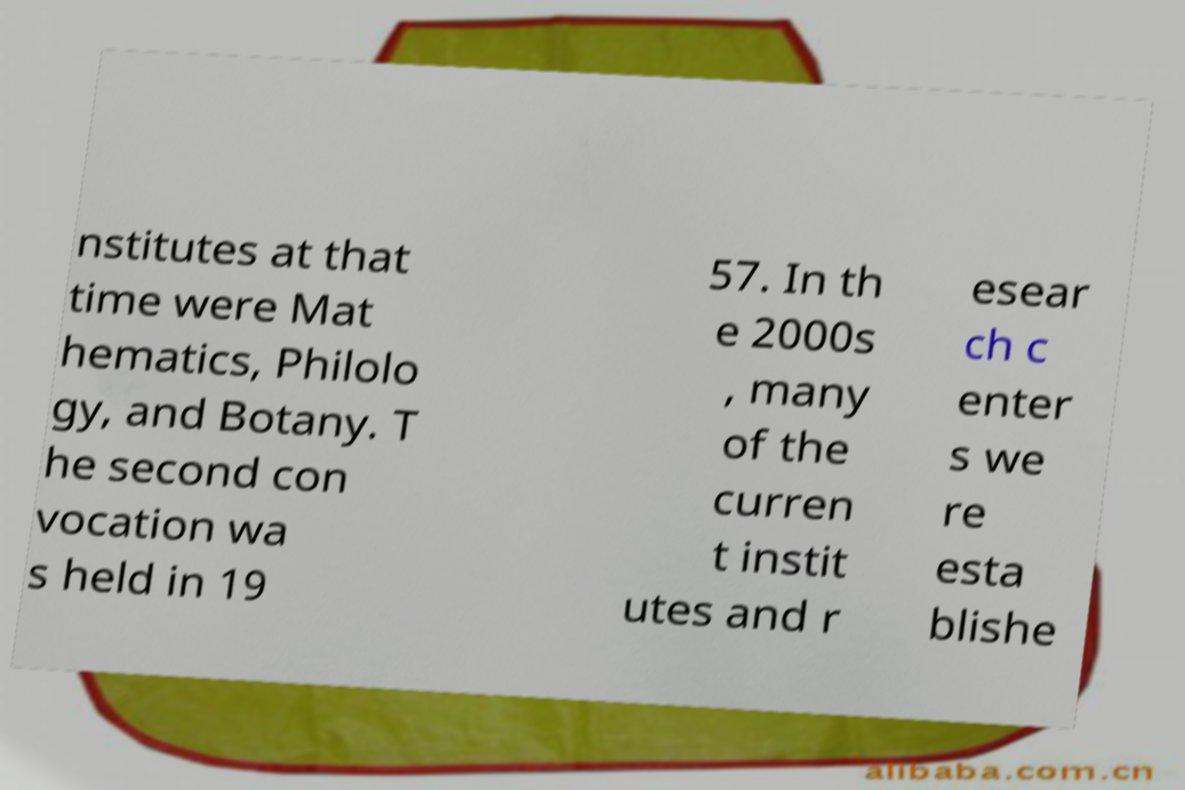Can you read and provide the text displayed in the image?This photo seems to have some interesting text. Can you extract and type it out for me? nstitutes at that time were Mat hematics, Philolo gy, and Botany. T he second con vocation wa s held in 19 57. In th e 2000s , many of the curren t instit utes and r esear ch c enter s we re esta blishe 